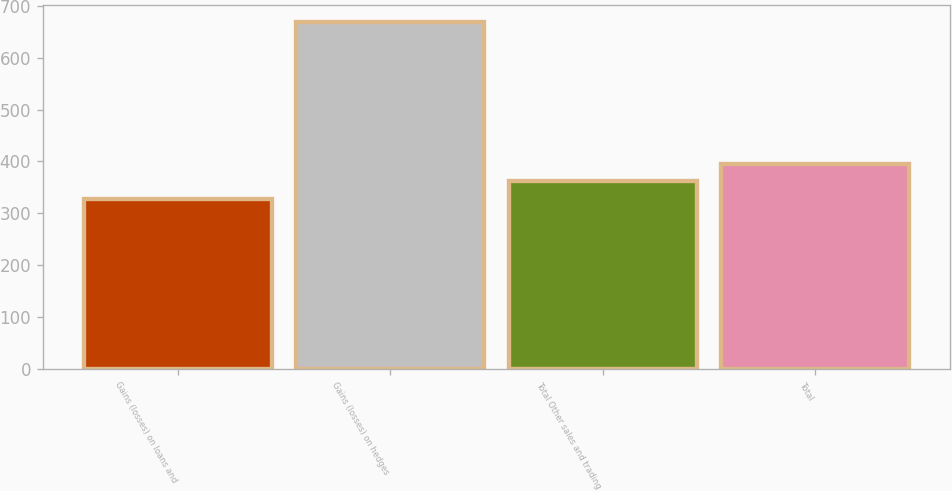Convert chart. <chart><loc_0><loc_0><loc_500><loc_500><bar_chart><fcel>Gains (losses) on loans and<fcel>Gains (losses) on hedges<fcel>Total Other sales and trading<fcel>Total<nl><fcel>327<fcel>669<fcel>361.2<fcel>395.4<nl></chart> 